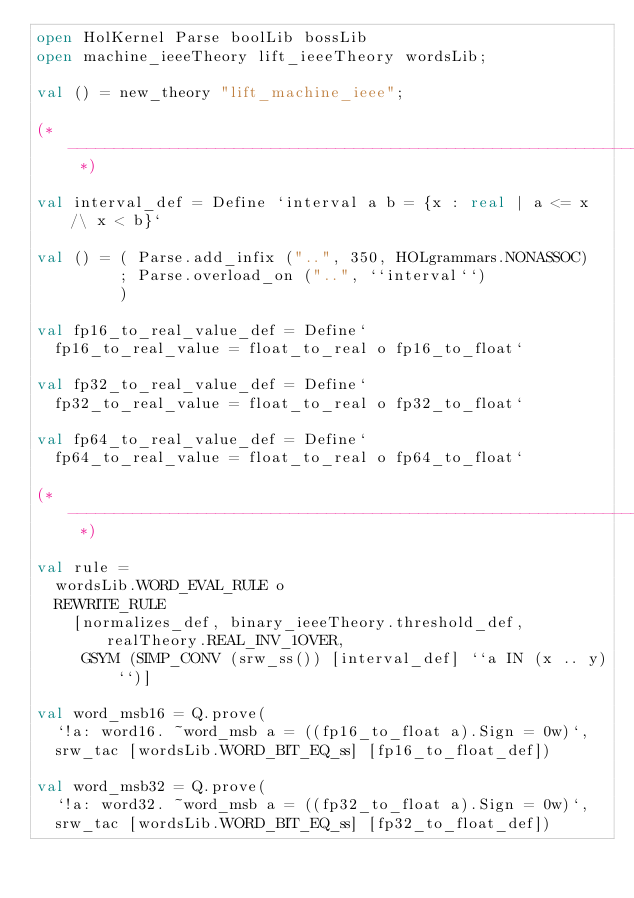Convert code to text. <code><loc_0><loc_0><loc_500><loc_500><_SML_>open HolKernel Parse boolLib bossLib
open machine_ieeeTheory lift_ieeeTheory wordsLib;

val () = new_theory "lift_machine_ieee";

(* --------------------------------------------------------------------- *)

val interval_def = Define `interval a b = {x : real | a <= x /\ x < b}`

val () = ( Parse.add_infix ("..", 350, HOLgrammars.NONASSOC)
         ; Parse.overload_on ("..", ``interval``)
         )

val fp16_to_real_value_def = Define`
  fp16_to_real_value = float_to_real o fp16_to_float`

val fp32_to_real_value_def = Define`
  fp32_to_real_value = float_to_real o fp32_to_float`

val fp64_to_real_value_def = Define`
  fp64_to_real_value = float_to_real o fp64_to_float`

(* --------------------------------------------------------------------- *)

val rule =
  wordsLib.WORD_EVAL_RULE o
  REWRITE_RULE
    [normalizes_def, binary_ieeeTheory.threshold_def, realTheory.REAL_INV_1OVER,
     GSYM (SIMP_CONV (srw_ss()) [interval_def] ``a IN (x .. y)``)]

val word_msb16 = Q.prove(
  `!a: word16. ~word_msb a = ((fp16_to_float a).Sign = 0w)`,
  srw_tac [wordsLib.WORD_BIT_EQ_ss] [fp16_to_float_def])

val word_msb32 = Q.prove(
  `!a: word32. ~word_msb a = ((fp32_to_float a).Sign = 0w)`,
  srw_tac [wordsLib.WORD_BIT_EQ_ss] [fp32_to_float_def])
</code> 